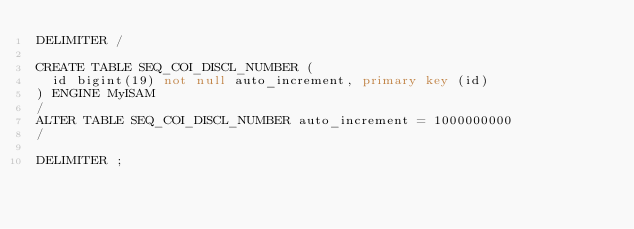Convert code to text. <code><loc_0><loc_0><loc_500><loc_500><_SQL_>DELIMITER /

CREATE TABLE SEQ_COI_DISCL_NUMBER (
  id bigint(19) not null auto_increment, primary key (id)
) ENGINE MyISAM
/
ALTER TABLE SEQ_COI_DISCL_NUMBER auto_increment = 1000000000
/

DELIMITER ;
</code> 